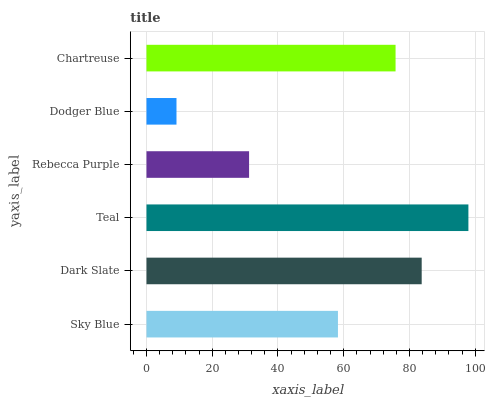Is Dodger Blue the minimum?
Answer yes or no. Yes. Is Teal the maximum?
Answer yes or no. Yes. Is Dark Slate the minimum?
Answer yes or no. No. Is Dark Slate the maximum?
Answer yes or no. No. Is Dark Slate greater than Sky Blue?
Answer yes or no. Yes. Is Sky Blue less than Dark Slate?
Answer yes or no. Yes. Is Sky Blue greater than Dark Slate?
Answer yes or no. No. Is Dark Slate less than Sky Blue?
Answer yes or no. No. Is Chartreuse the high median?
Answer yes or no. Yes. Is Sky Blue the low median?
Answer yes or no. Yes. Is Teal the high median?
Answer yes or no. No. Is Chartreuse the low median?
Answer yes or no. No. 